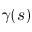<formula> <loc_0><loc_0><loc_500><loc_500>\gamma ( s )</formula> 